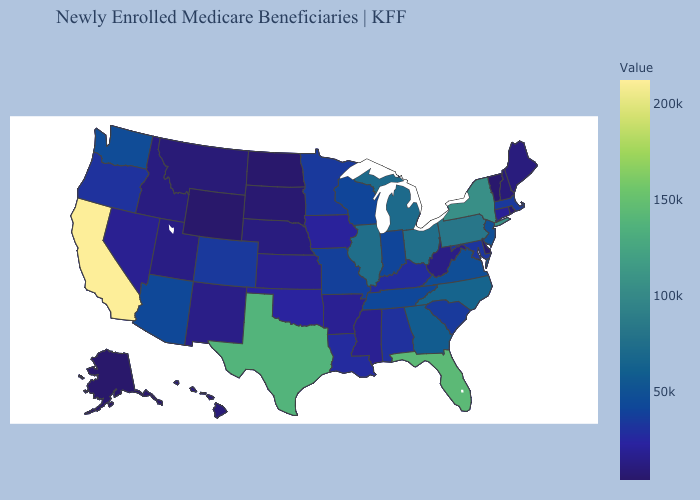Does Colorado have a lower value than Hawaii?
Concise answer only. No. Which states hav the highest value in the MidWest?
Be succinct. Ohio. Among the states that border Louisiana , which have the lowest value?
Answer briefly. Arkansas. Which states have the highest value in the USA?
Quick response, please. California. Does Utah have the highest value in the West?
Answer briefly. No. Which states have the highest value in the USA?
Keep it brief. California. 